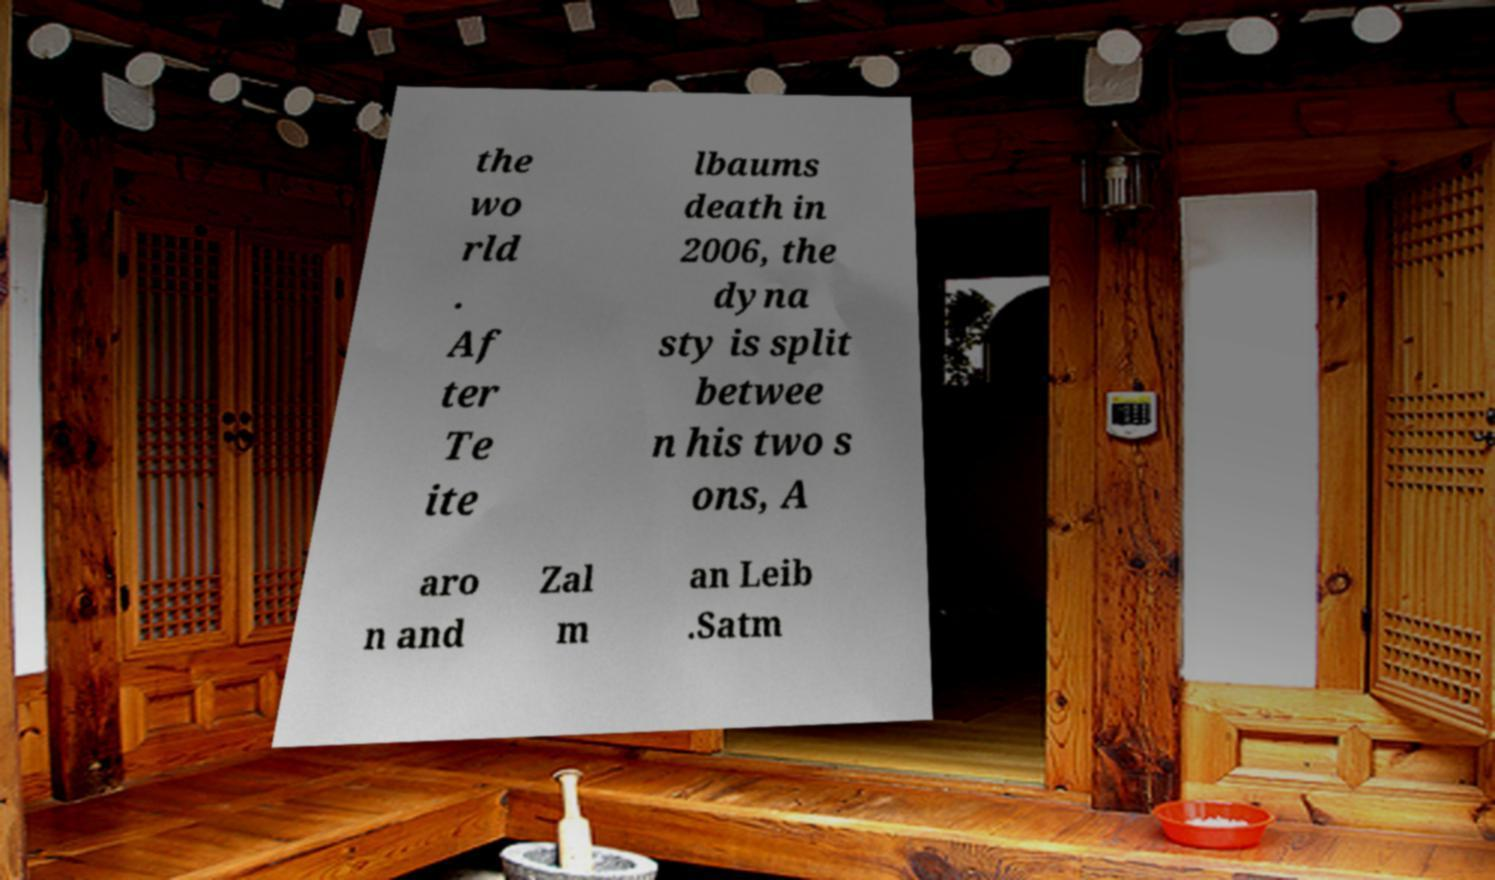Please identify and transcribe the text found in this image. the wo rld . Af ter Te ite lbaums death in 2006, the dyna sty is split betwee n his two s ons, A aro n and Zal m an Leib .Satm 